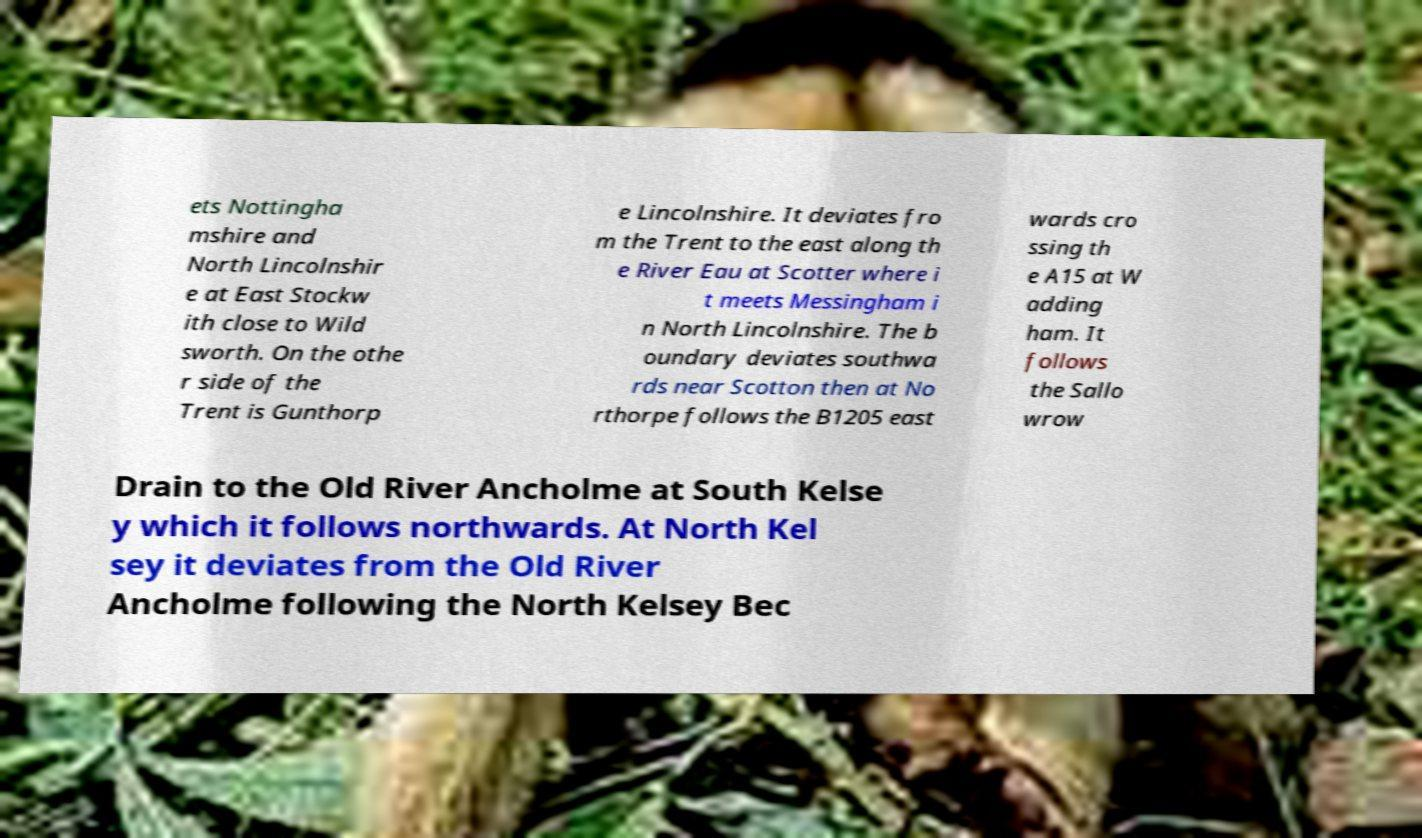Please read and relay the text visible in this image. What does it say? ets Nottingha mshire and North Lincolnshir e at East Stockw ith close to Wild sworth. On the othe r side of the Trent is Gunthorp e Lincolnshire. It deviates fro m the Trent to the east along th e River Eau at Scotter where i t meets Messingham i n North Lincolnshire. The b oundary deviates southwa rds near Scotton then at No rthorpe follows the B1205 east wards cro ssing th e A15 at W adding ham. It follows the Sallo wrow Drain to the Old River Ancholme at South Kelse y which it follows northwards. At North Kel sey it deviates from the Old River Ancholme following the North Kelsey Bec 